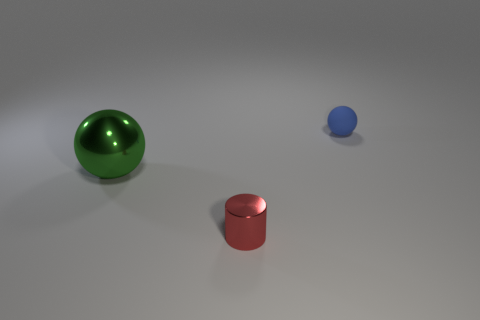Are there any large brown metal things of the same shape as the green thing?
Your answer should be compact. No. How many other things are the same shape as the blue matte thing?
Give a very brief answer. 1. Is the shape of the matte object the same as the metallic thing that is to the left of the red metallic cylinder?
Give a very brief answer. Yes. Are there any other things that are the same material as the tiny ball?
Provide a succinct answer. No. There is a large green object that is the same shape as the tiny blue object; what is its material?
Your response must be concise. Metal. How many tiny things are green objects or matte objects?
Offer a very short reply. 1. Is the number of tiny balls in front of the tiny blue sphere less than the number of metal things right of the green thing?
Your answer should be very brief. Yes. What number of things are matte things or big blue shiny balls?
Make the answer very short. 1. There is a large ball; what number of small red shiny cylinders are on the left side of it?
Your answer should be very brief. 0. Is the color of the rubber ball the same as the shiny ball?
Make the answer very short. No. 